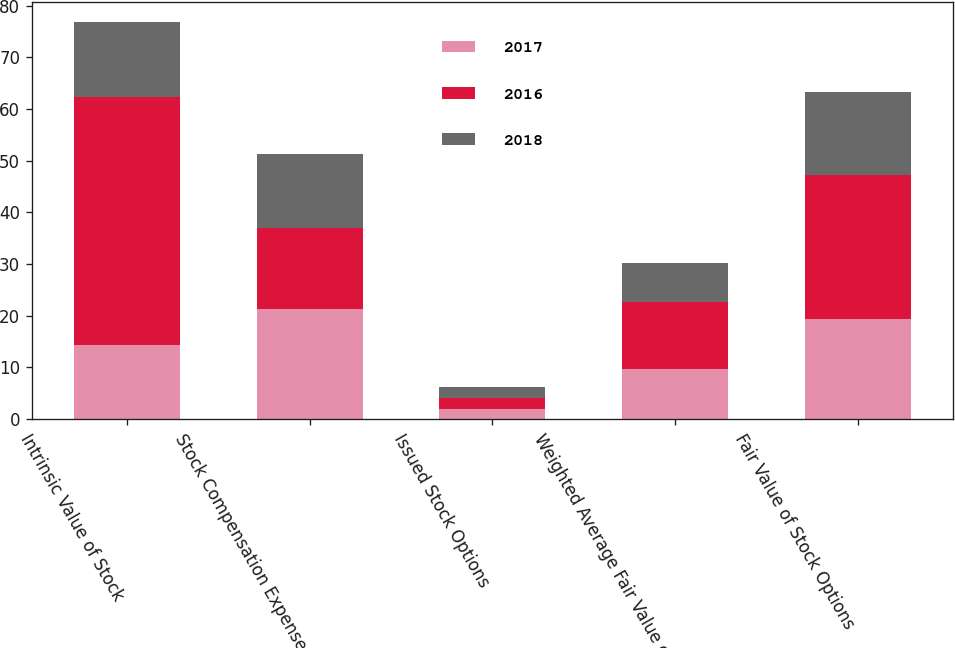Convert chart to OTSL. <chart><loc_0><loc_0><loc_500><loc_500><stacked_bar_chart><ecel><fcel>Intrinsic Value of Stock<fcel>Stock Compensation Expense<fcel>Issued Stock Options<fcel>Weighted Average Fair Value of<fcel>Fair Value of Stock Options<nl><fcel>2017<fcel>14.4<fcel>21.3<fcel>2<fcel>9.79<fcel>19.4<nl><fcel>2016<fcel>48<fcel>15.7<fcel>2.1<fcel>12.9<fcel>27.8<nl><fcel>2018<fcel>14.4<fcel>14.4<fcel>2.1<fcel>7.57<fcel>16.1<nl></chart> 